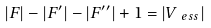Convert formula to latex. <formula><loc_0><loc_0><loc_500><loc_500>| F | - | F ^ { \prime } | - | F ^ { \prime \prime } | + 1 = | V _ { \ e s s } |</formula> 